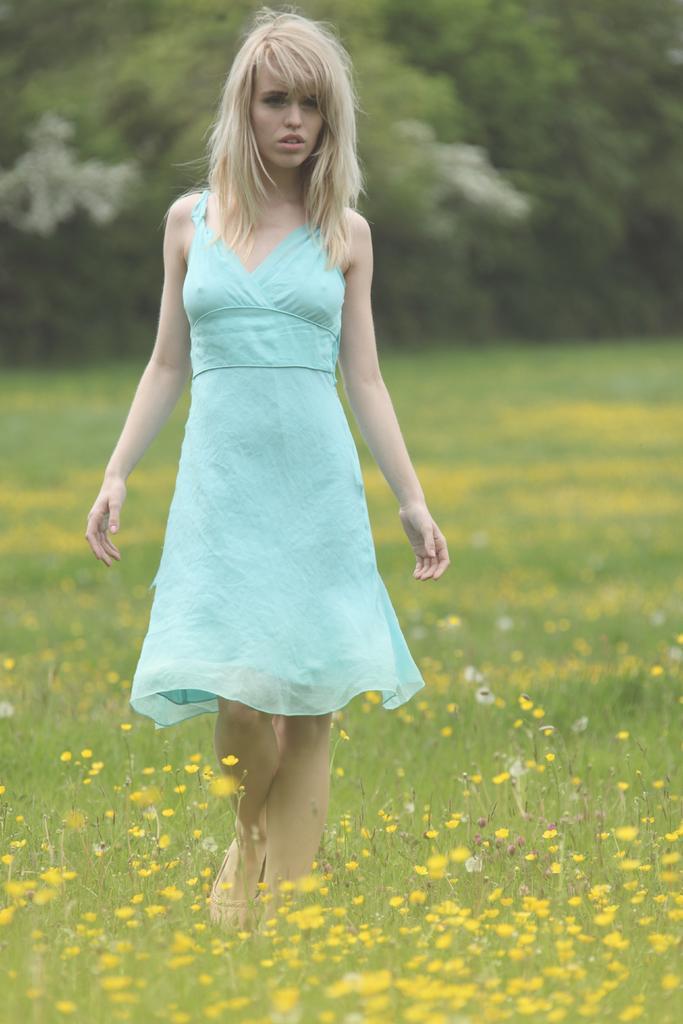Please provide a concise description of this image. In this image we can see a woman. Here we can see grass and flowers. In the background there are trees. 